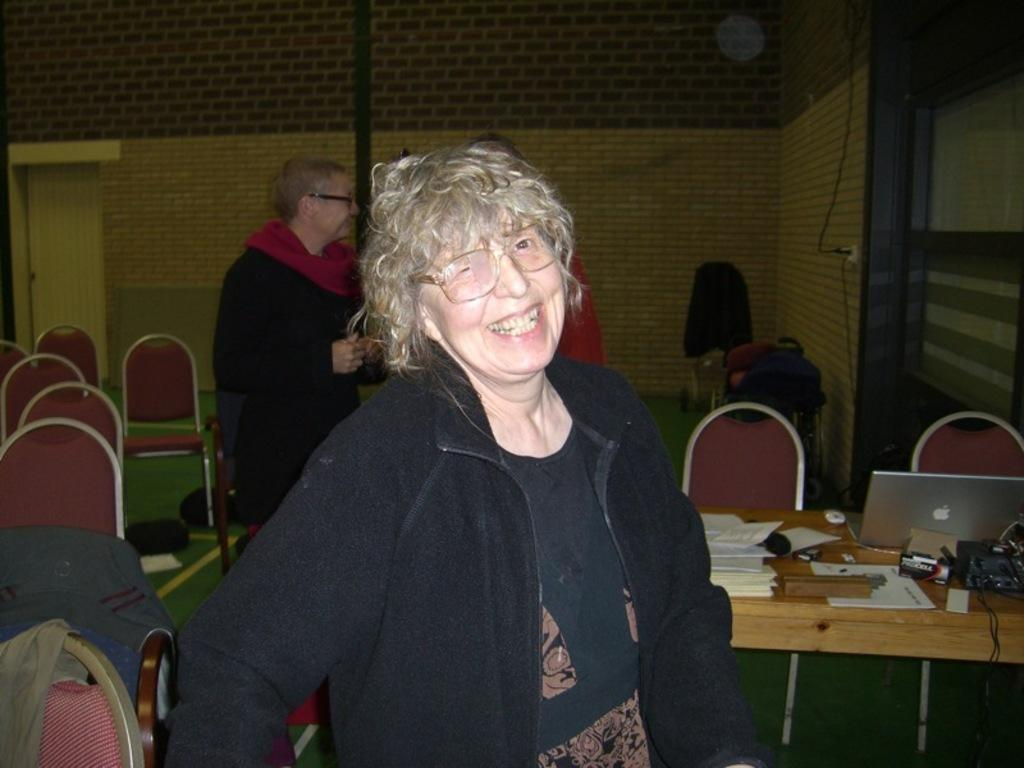Who is present in the image? There is a woman and a man in the image. What is the woman doing in the image? The woman is smiling in the image. How is the man positioned in relation to the woman? The man is standing behind the woman in the image. What type of furniture is visible in the image? There are chairs in the image. What electronic device can be seen on a table in the image? There is a laptop on a table in the image. What type of rod can be seen in the woman's hand in the image? There is no rod present in the woman's hand or anywhere else in the image. What phase of the moon is visible in the image? The image does not show the moon or any celestial bodies; it is focused on the people and objects in the room. 